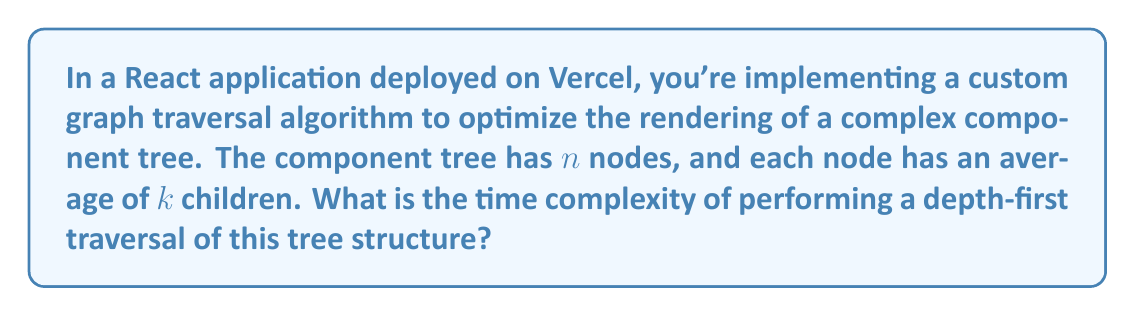Teach me how to tackle this problem. To determine the time complexity of the depth-first traversal algorithm for the React component tree, let's break down the problem:

1. Tree structure:
   - Total number of nodes: $n$
   - Average number of children per node: $k$

2. Depth-first traversal:
   - Visits each node exactly once
   - For each node, it explores all of its children

3. Analysis:
   a. The algorithm will visit all $n$ nodes.
   b. For each node, it will perform $O(k)$ operations to explore its children.

4. Total operations:
   - Number of nodes × Operations per node
   - $n \times O(k) = O(nk)$

5. Tree height consideration:
   - In a tree with $n$ nodes and $k$ children per node, the height $h$ is approximately $\log_k(n)$
   - However, this doesn't affect the overall time complexity in this case

6. Optimization note:
   - In React, optimization techniques like memoization or virtual DOM diffing might be used
   - These optimizations don't change the fundamental time complexity of traversing all nodes

Therefore, the time complexity of performing a depth-first traversal of the React component tree is $O(nk)$, where $n$ is the total number of nodes and $k$ is the average number of children per node.
Answer: $O(nk)$ 